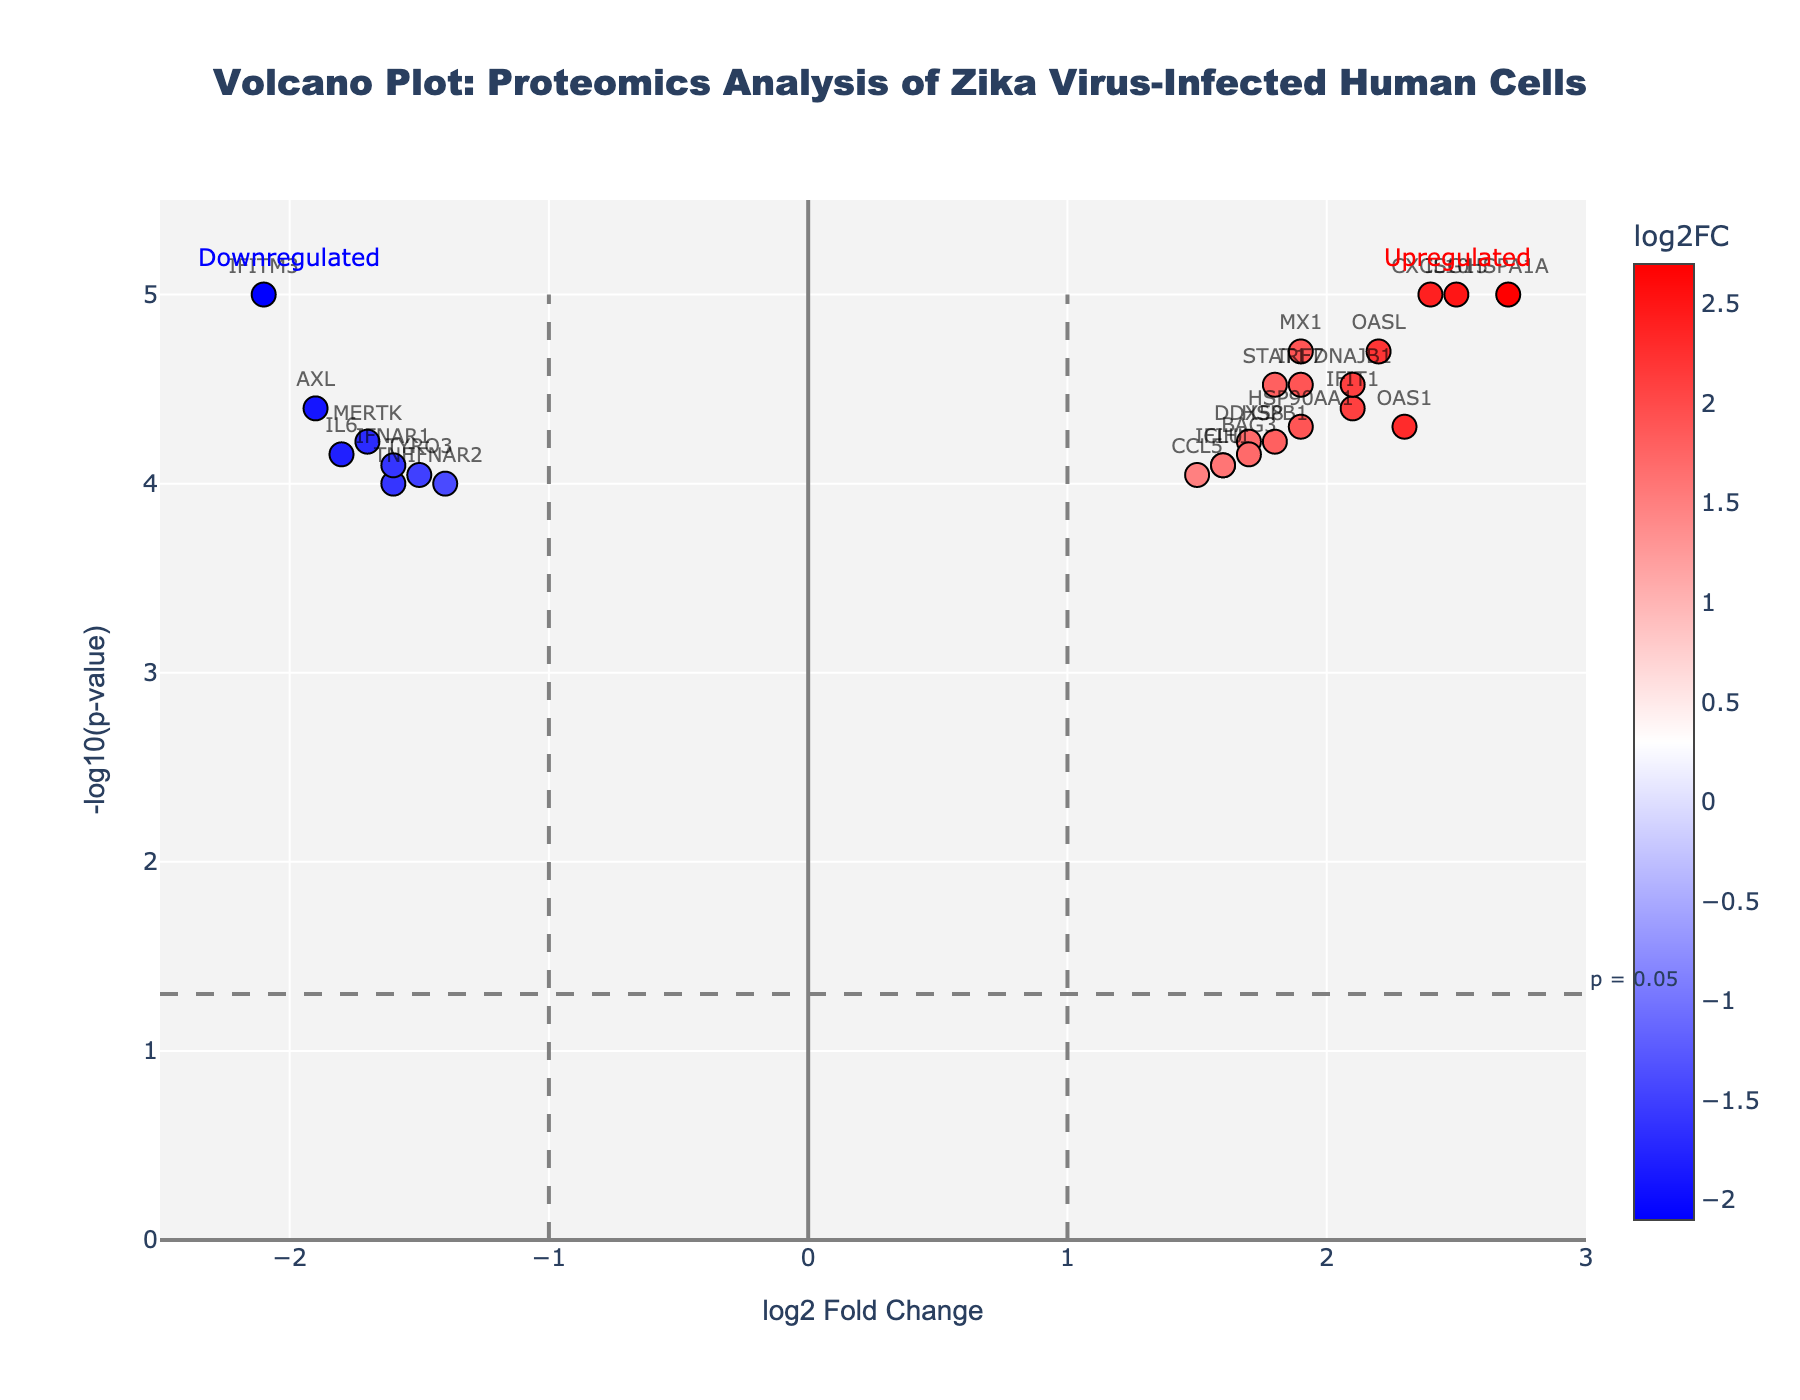What is the title of the volcano plot? The title of the plot is given at the top. It reads, "Volcano Plot: Proteomics Analysis of Zika Virus-Infected Human Cells."
Answer: "Volcano Plot: Proteomics Analysis of Zika Virus-Infected Human Cells" What does the x-axis represent in the plot? The label of the x-axis indicates it represents "log2 Fold Change," which measures the change in expression levels of genes.
Answer: log2 Fold Change What is used to color the data points in the plot? The color of the data points is based on their log2 Fold Change values, where different colors indicate the upregulation or downregulation of genes. The color bar shown on the side offers a visual reference.
Answer: log2 Fold Change values Which gene has the highest log2 Fold Change? The gene labeled "HSPA1A" positioned at the far right of the plot at a log2 Fold Change of 2.7 has the highest value.
Answer: HSPA1A Which gene has the lowest log2 Fold Change? The gene labeled "IFITM3" positioned at the far left of the plot at a log2 Fold Change of -2.1 has the lowest value.
Answer: IFITM3 Which genes have a log2 Fold Change greater than 2? By scanning the plot, the genes with log2 Fold Changes greater than 2 include "HSPA1A," "ISG15," "OAS1," "CXCL10," and "OASL."
Answer: HSPA1A, ISG15, OAS1, CXCL10, OASL How many genes have a -log10(p-value) greater than or equal to 4? By counting the points with -log10(p-values) greater than or equal to 4, we find that there are five such genes: "IFITM3," "STAT1," "OAS1," "MX1," and "ISG15."
Answer: Five What is the p-value threshold indicated in the plot, and why is it important? The plot includes a horizontal line indicating the p-value threshold at -log10(p-value) = 1.3, which corresponds to a significance level of p = 0.05. This threshold is important for distinguishing between statistically significant and non-significant results.
Answer: p = 0.05 Which genes are downregulated and below the p-value threshold? These are the genes positioned to the left of the log2 Fold Change of 0 and below the -log10(p-value) threshold line: "AXL" and "TYRO3."
Answer: AXL, TYRO3 How many genes are upregulated and above the p-value threshold? Counting the genes on the right of the log2 Fold Change of 0 and above the -log10(p-value) threshold line, we find there are ten such genes: "STAT1," "OAS1," "MX1," "ISG15," "IFIT1," "IRF7," "OASL," "CXCL10," "DNAJB1" and "HSPA1A."
Answer: Ten 